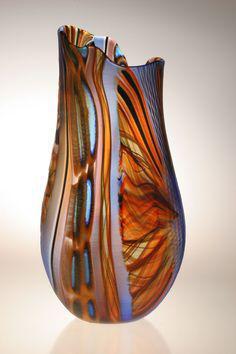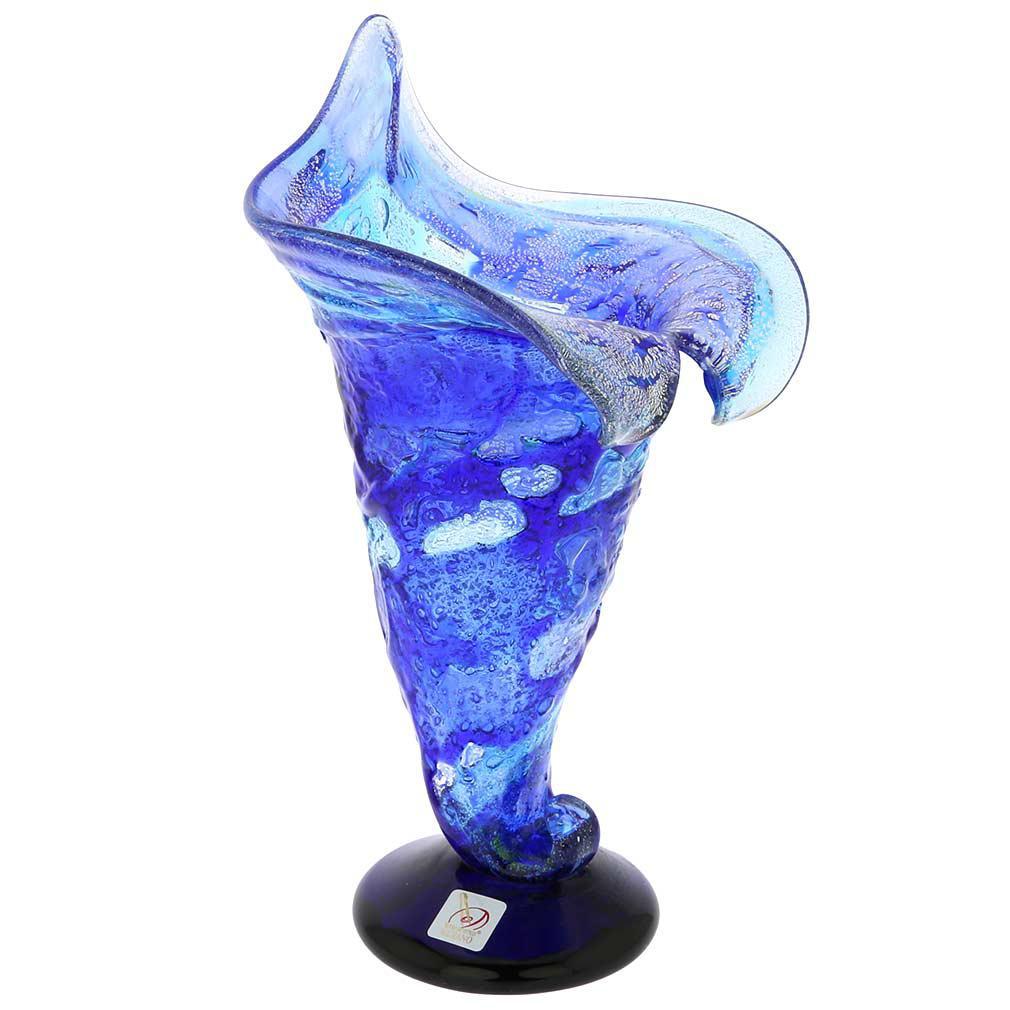The first image is the image on the left, the second image is the image on the right. Given the left and right images, does the statement "An image shows one translucent blue vase with a deep blue non-scalloped base." hold true? Answer yes or no. Yes. 